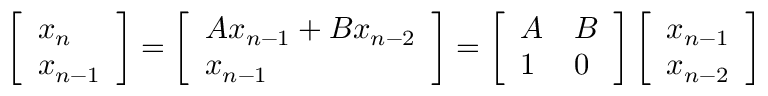<formula> <loc_0><loc_0><loc_500><loc_500>\left [ \begin{array} { l } { x _ { n } } \\ { x _ { n - 1 } } \end{array} \right ] = \left [ \begin{array} { l } { A x _ { n - 1 } + B x _ { n - 2 } } \\ { x _ { n - 1 } } \end{array} \right ] = \left [ \begin{array} { l l } { A } & { B } \\ { 1 } & { 0 } \end{array} \right ] \left [ \begin{array} { l } { x _ { n - 1 } } \\ { x _ { n - 2 } } \end{array} \right ]</formula> 